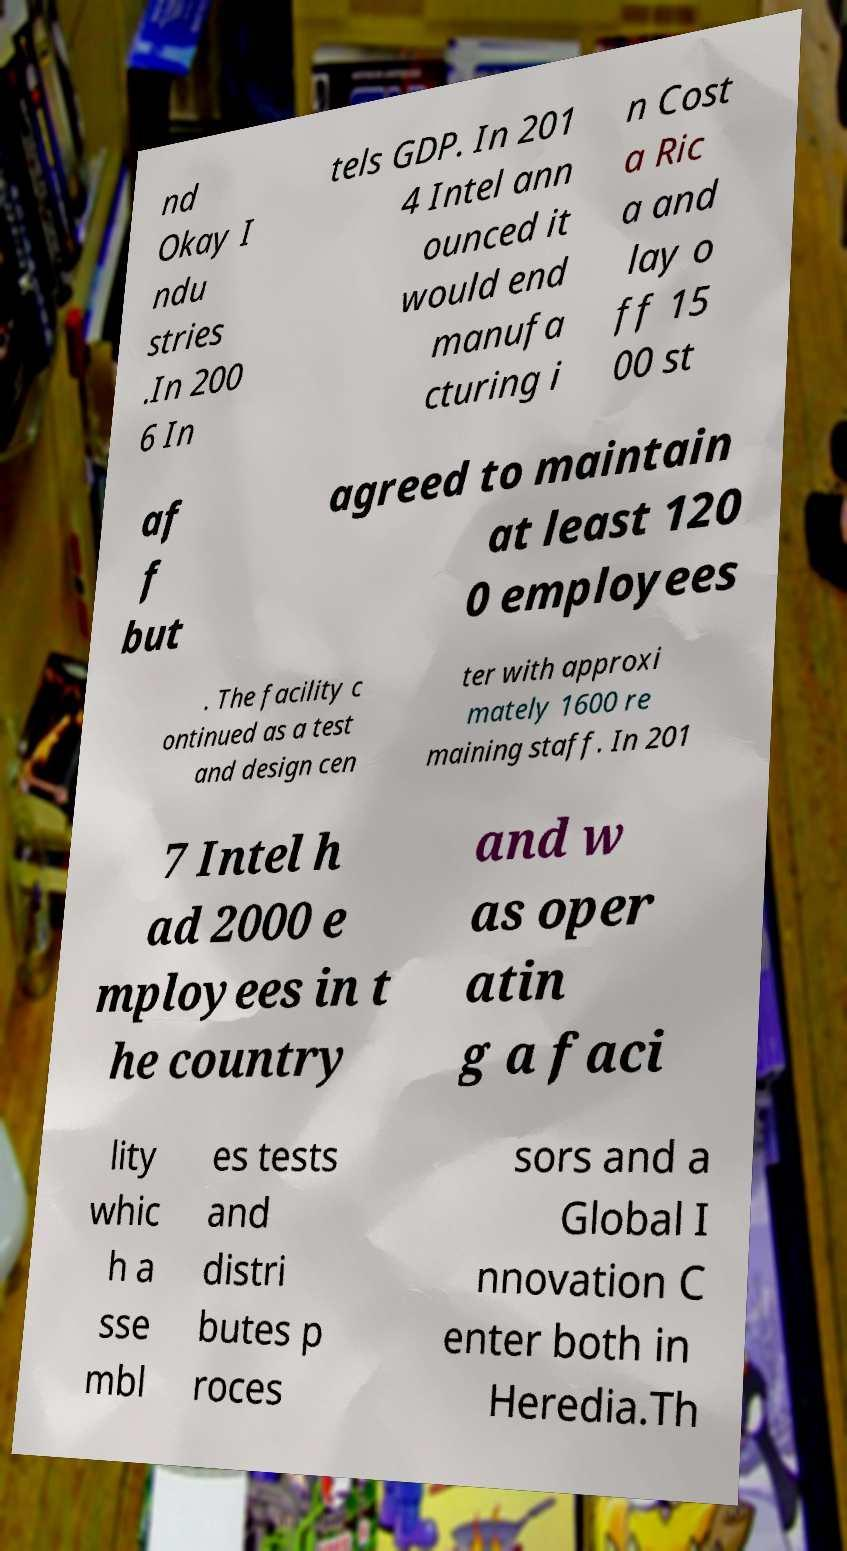Please read and relay the text visible in this image. What does it say? nd Okay I ndu stries .In 200 6 In tels GDP. In 201 4 Intel ann ounced it would end manufa cturing i n Cost a Ric a and lay o ff 15 00 st af f but agreed to maintain at least 120 0 employees . The facility c ontinued as a test and design cen ter with approxi mately 1600 re maining staff. In 201 7 Intel h ad 2000 e mployees in t he country and w as oper atin g a faci lity whic h a sse mbl es tests and distri butes p roces sors and a Global I nnovation C enter both in Heredia.Th 